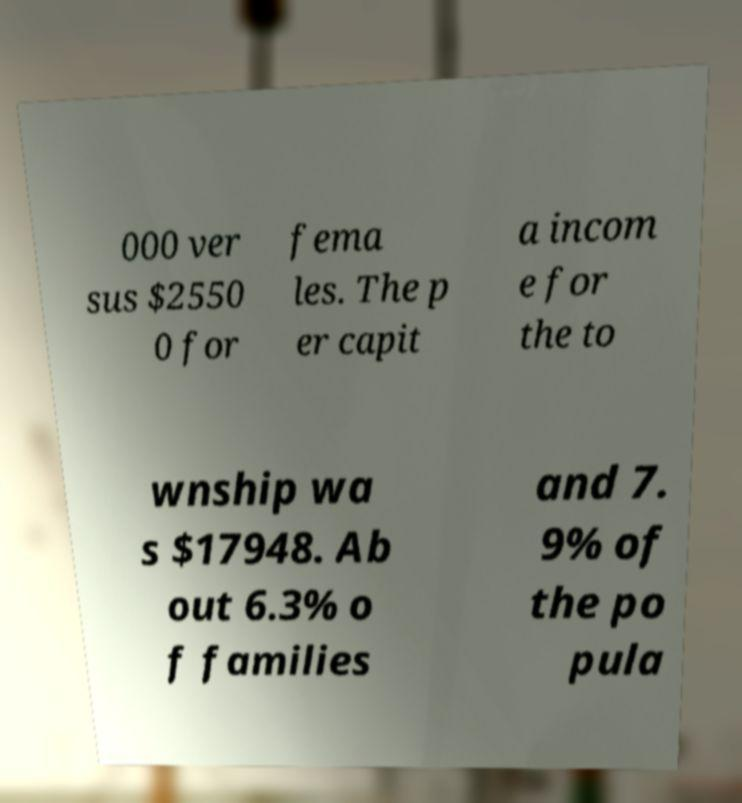Please identify and transcribe the text found in this image. 000 ver sus $2550 0 for fema les. The p er capit a incom e for the to wnship wa s $17948. Ab out 6.3% o f families and 7. 9% of the po pula 